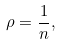<formula> <loc_0><loc_0><loc_500><loc_500>\rho = \frac { 1 } { n } ,</formula> 